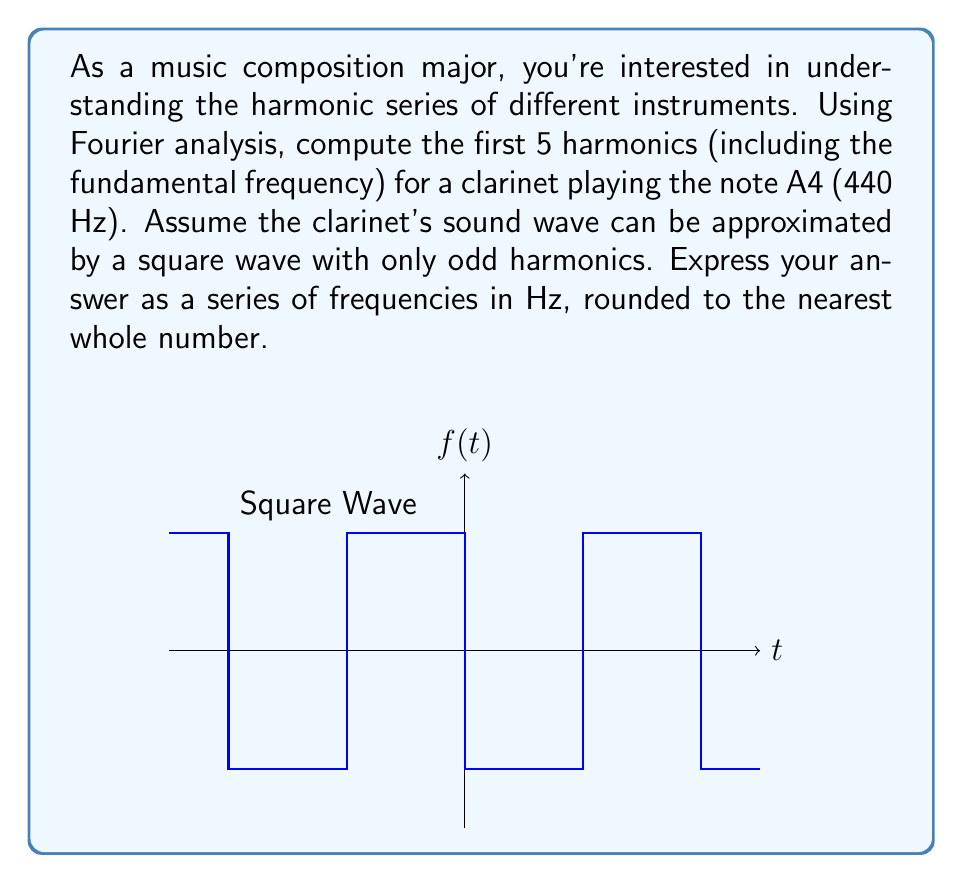Show me your answer to this math problem. Let's approach this step-by-step:

1) The fundamental frequency (1st harmonic) of A4 is 440 Hz.

2) For a square wave, the Fourier series is given by:

   $$f(t) = \frac{4}{\pi} \sum_{n=1,3,5,...}^{\infty} \frac{1}{n} \sin(2\pi n f_0 t)$$

   where $f_0$ is the fundamental frequency.

3) The frequencies of the harmonics are given by $n f_0$, where $n$ is the harmonic number.

4) For a clarinet (approximated as a square wave), we only consider odd harmonics. So, the first 5 harmonics will be:

   1st harmonic (fundamental): $1 \times 440 = 440$ Hz
   3rd harmonic: $3 \times 440 = 1320$ Hz
   5th harmonic: $5 \times 440 = 2200$ Hz
   7th harmonic: $7 \times 440 = 3080$ Hz
   9th harmonic: $9 \times 440 = 3960$ Hz

5) Rounding to the nearest whole number (which is only necessary for the last value):

   440 Hz, 1320 Hz, 2200 Hz, 3080 Hz, 3960 Hz

These frequencies represent the first 5 harmonics in the harmonic series of a clarinet playing A4, based on the square wave approximation.
Answer: 440, 1320, 2200, 3080, 3960 